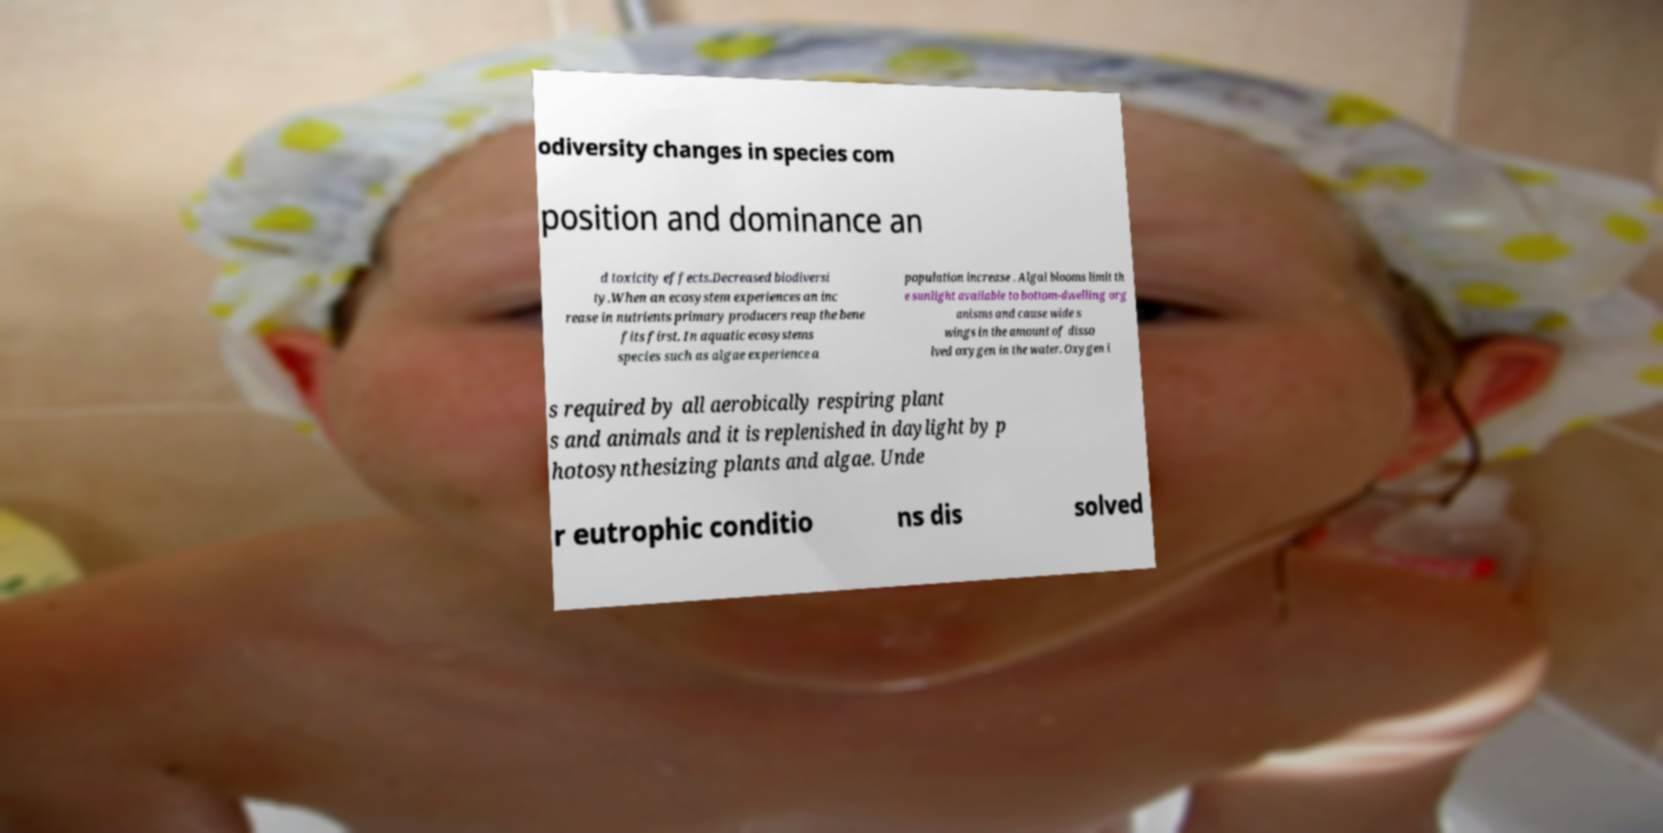For documentation purposes, I need the text within this image transcribed. Could you provide that? odiversity changes in species com position and dominance an d toxicity effects.Decreased biodiversi ty.When an ecosystem experiences an inc rease in nutrients primary producers reap the bene fits first. In aquatic ecosystems species such as algae experience a population increase . Algal blooms limit th e sunlight available to bottom-dwelling org anisms and cause wide s wings in the amount of disso lved oxygen in the water. Oxygen i s required by all aerobically respiring plant s and animals and it is replenished in daylight by p hotosynthesizing plants and algae. Unde r eutrophic conditio ns dis solved 